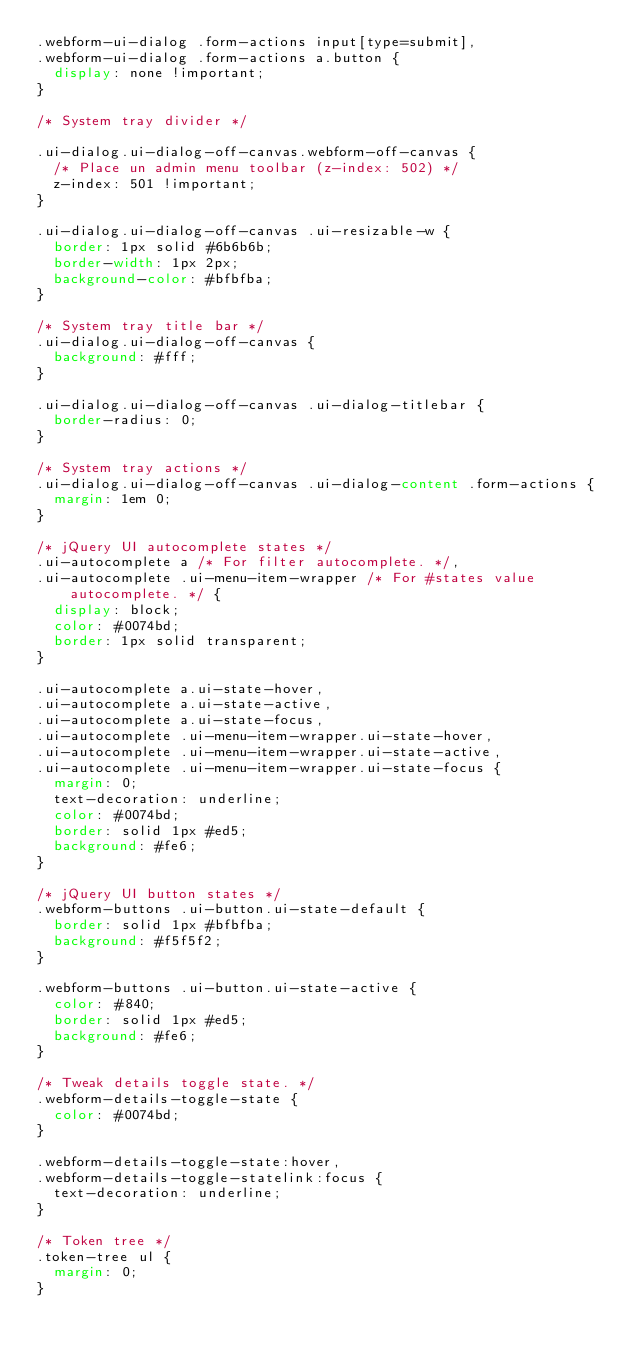<code> <loc_0><loc_0><loc_500><loc_500><_CSS_>.webform-ui-dialog .form-actions input[type=submit],
.webform-ui-dialog .form-actions a.button {
  display: none !important;
}

/* System tray divider */

.ui-dialog.ui-dialog-off-canvas.webform-off-canvas {
  /* Place un admin menu toolbar (z-index: 502) */
  z-index: 501 !important;
}

.ui-dialog.ui-dialog-off-canvas .ui-resizable-w {
  border: 1px solid #6b6b6b;
  border-width: 1px 2px;
  background-color: #bfbfba;
}

/* System tray title bar */
.ui-dialog.ui-dialog-off-canvas {
  background: #fff;
}

.ui-dialog.ui-dialog-off-canvas .ui-dialog-titlebar {
  border-radius: 0;
}

/* System tray actions */
.ui-dialog.ui-dialog-off-canvas .ui-dialog-content .form-actions {
  margin: 1em 0;
}

/* jQuery UI autocomplete states */
.ui-autocomplete a /* For filter autocomplete. */,
.ui-autocomplete .ui-menu-item-wrapper /* For #states value autocomplete. */ {
  display: block;
  color: #0074bd;
  border: 1px solid transparent;
}

.ui-autocomplete a.ui-state-hover,
.ui-autocomplete a.ui-state-active,
.ui-autocomplete a.ui-state-focus,
.ui-autocomplete .ui-menu-item-wrapper.ui-state-hover,
.ui-autocomplete .ui-menu-item-wrapper.ui-state-active,
.ui-autocomplete .ui-menu-item-wrapper.ui-state-focus {
  margin: 0;
  text-decoration: underline;
  color: #0074bd;
  border: solid 1px #ed5;
  background: #fe6;
}

/* jQuery UI button states */
.webform-buttons .ui-button.ui-state-default {
  border: solid 1px #bfbfba;
  background: #f5f5f2;
}

.webform-buttons .ui-button.ui-state-active {
  color: #840;
  border: solid 1px #ed5;
  background: #fe6;
}

/* Tweak details toggle state. */
.webform-details-toggle-state {
  color: #0074bd;
}

.webform-details-toggle-state:hover,
.webform-details-toggle-statelink:focus {
  text-decoration: underline;
}

/* Token tree */
.token-tree ul {
  margin: 0;
}
</code> 